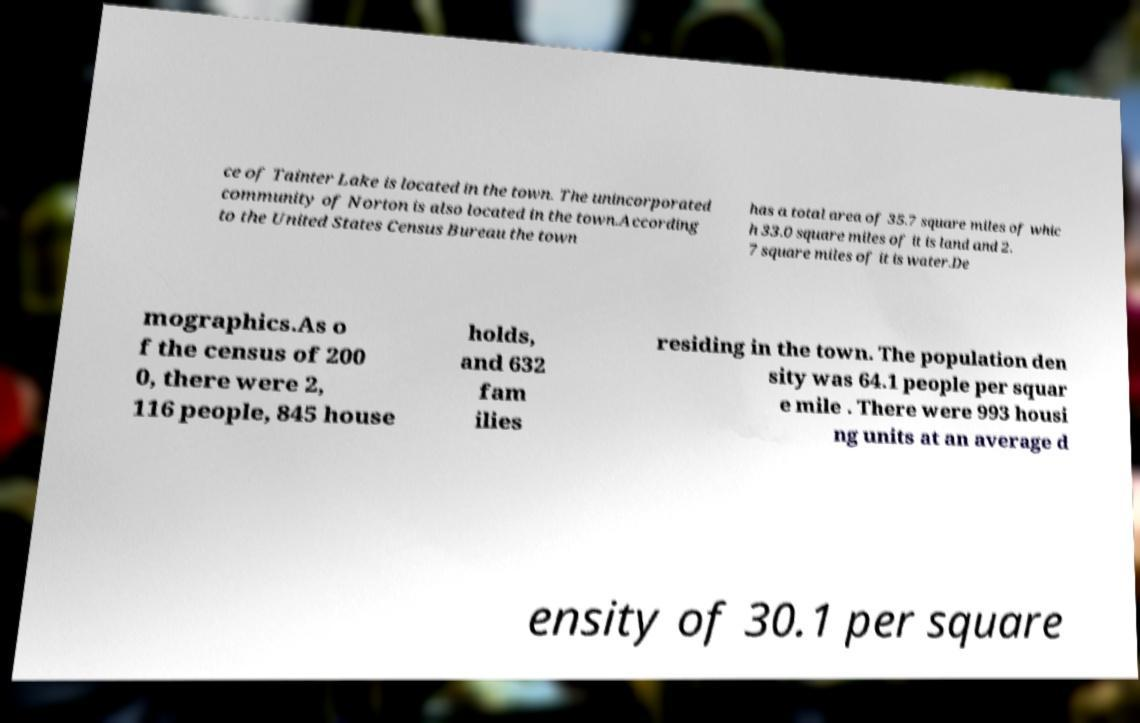What messages or text are displayed in this image? I need them in a readable, typed format. ce of Tainter Lake is located in the town. The unincorporated community of Norton is also located in the town.According to the United States Census Bureau the town has a total area of 35.7 square miles of whic h 33.0 square miles of it is land and 2. 7 square miles of it is water.De mographics.As o f the census of 200 0, there were 2, 116 people, 845 house holds, and 632 fam ilies residing in the town. The population den sity was 64.1 people per squar e mile . There were 993 housi ng units at an average d ensity of 30.1 per square 